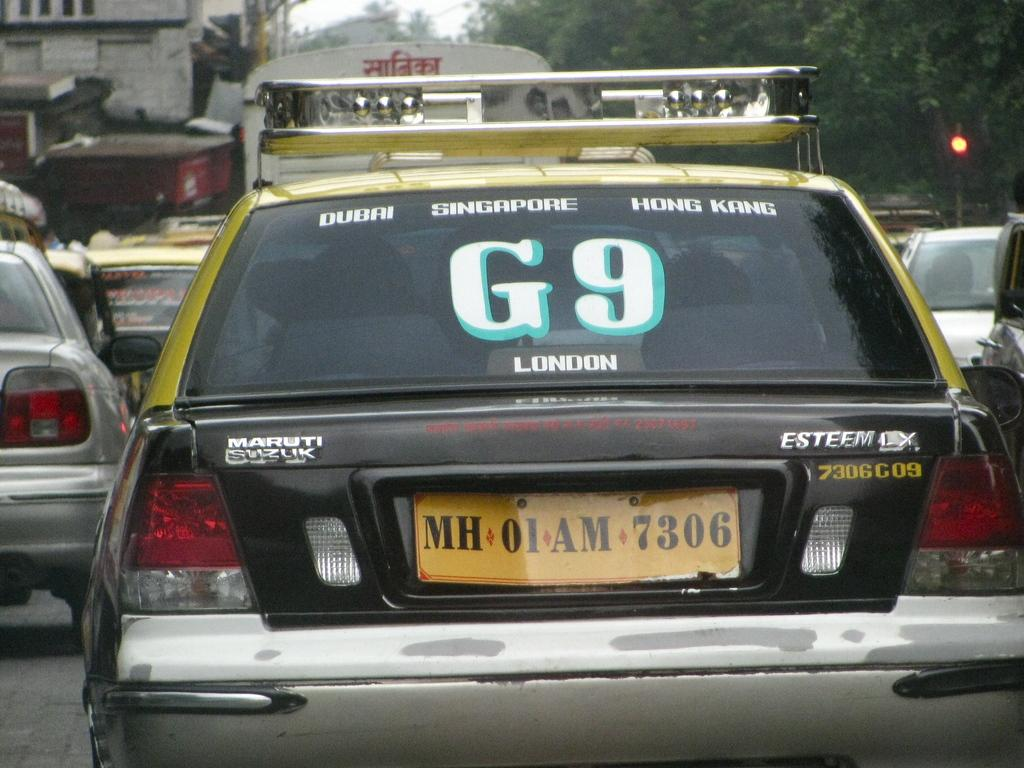Provide a one-sentence caption for the provided image. A car has G9 in white and green outlines on the back window. 